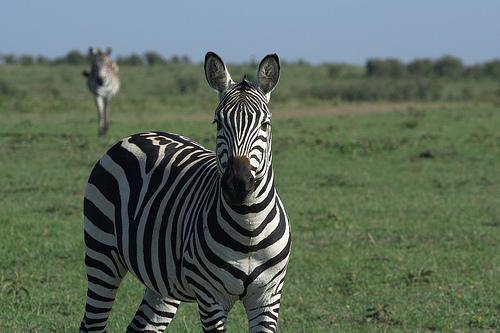How many zebras?
Give a very brief answer. 2. 